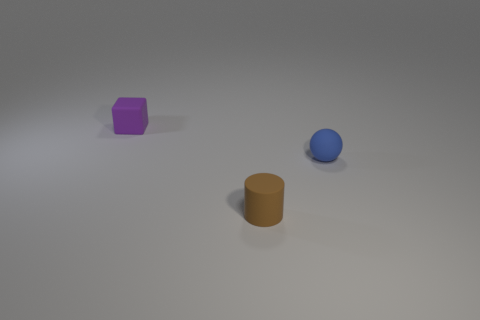There is a small thing that is right of the tiny object that is in front of the tiny object that is to the right of the brown rubber object; what is its material?
Give a very brief answer. Rubber. Is there another tiny ball of the same color as the rubber sphere?
Provide a succinct answer. No. Are there fewer tiny purple rubber things that are right of the cube than big red shiny cubes?
Provide a short and direct response. No. There is a object behind the blue ball; is it the same size as the small brown cylinder?
Make the answer very short. Yes. What number of matte things are both right of the small brown rubber cylinder and behind the small blue rubber thing?
Ensure brevity in your answer.  0. How big is the matte object that is behind the thing to the right of the brown thing?
Provide a short and direct response. Small. Is the number of tiny blue rubber things that are behind the blue rubber thing less than the number of small purple objects behind the small purple thing?
Make the answer very short. No. There is a thing that is to the right of the cylinder; does it have the same color as the small object behind the matte ball?
Offer a terse response. No. The tiny object that is on the right side of the purple rubber thing and left of the tiny blue ball is made of what material?
Provide a succinct answer. Rubber. Are there any brown rubber things?
Give a very brief answer. Yes. 